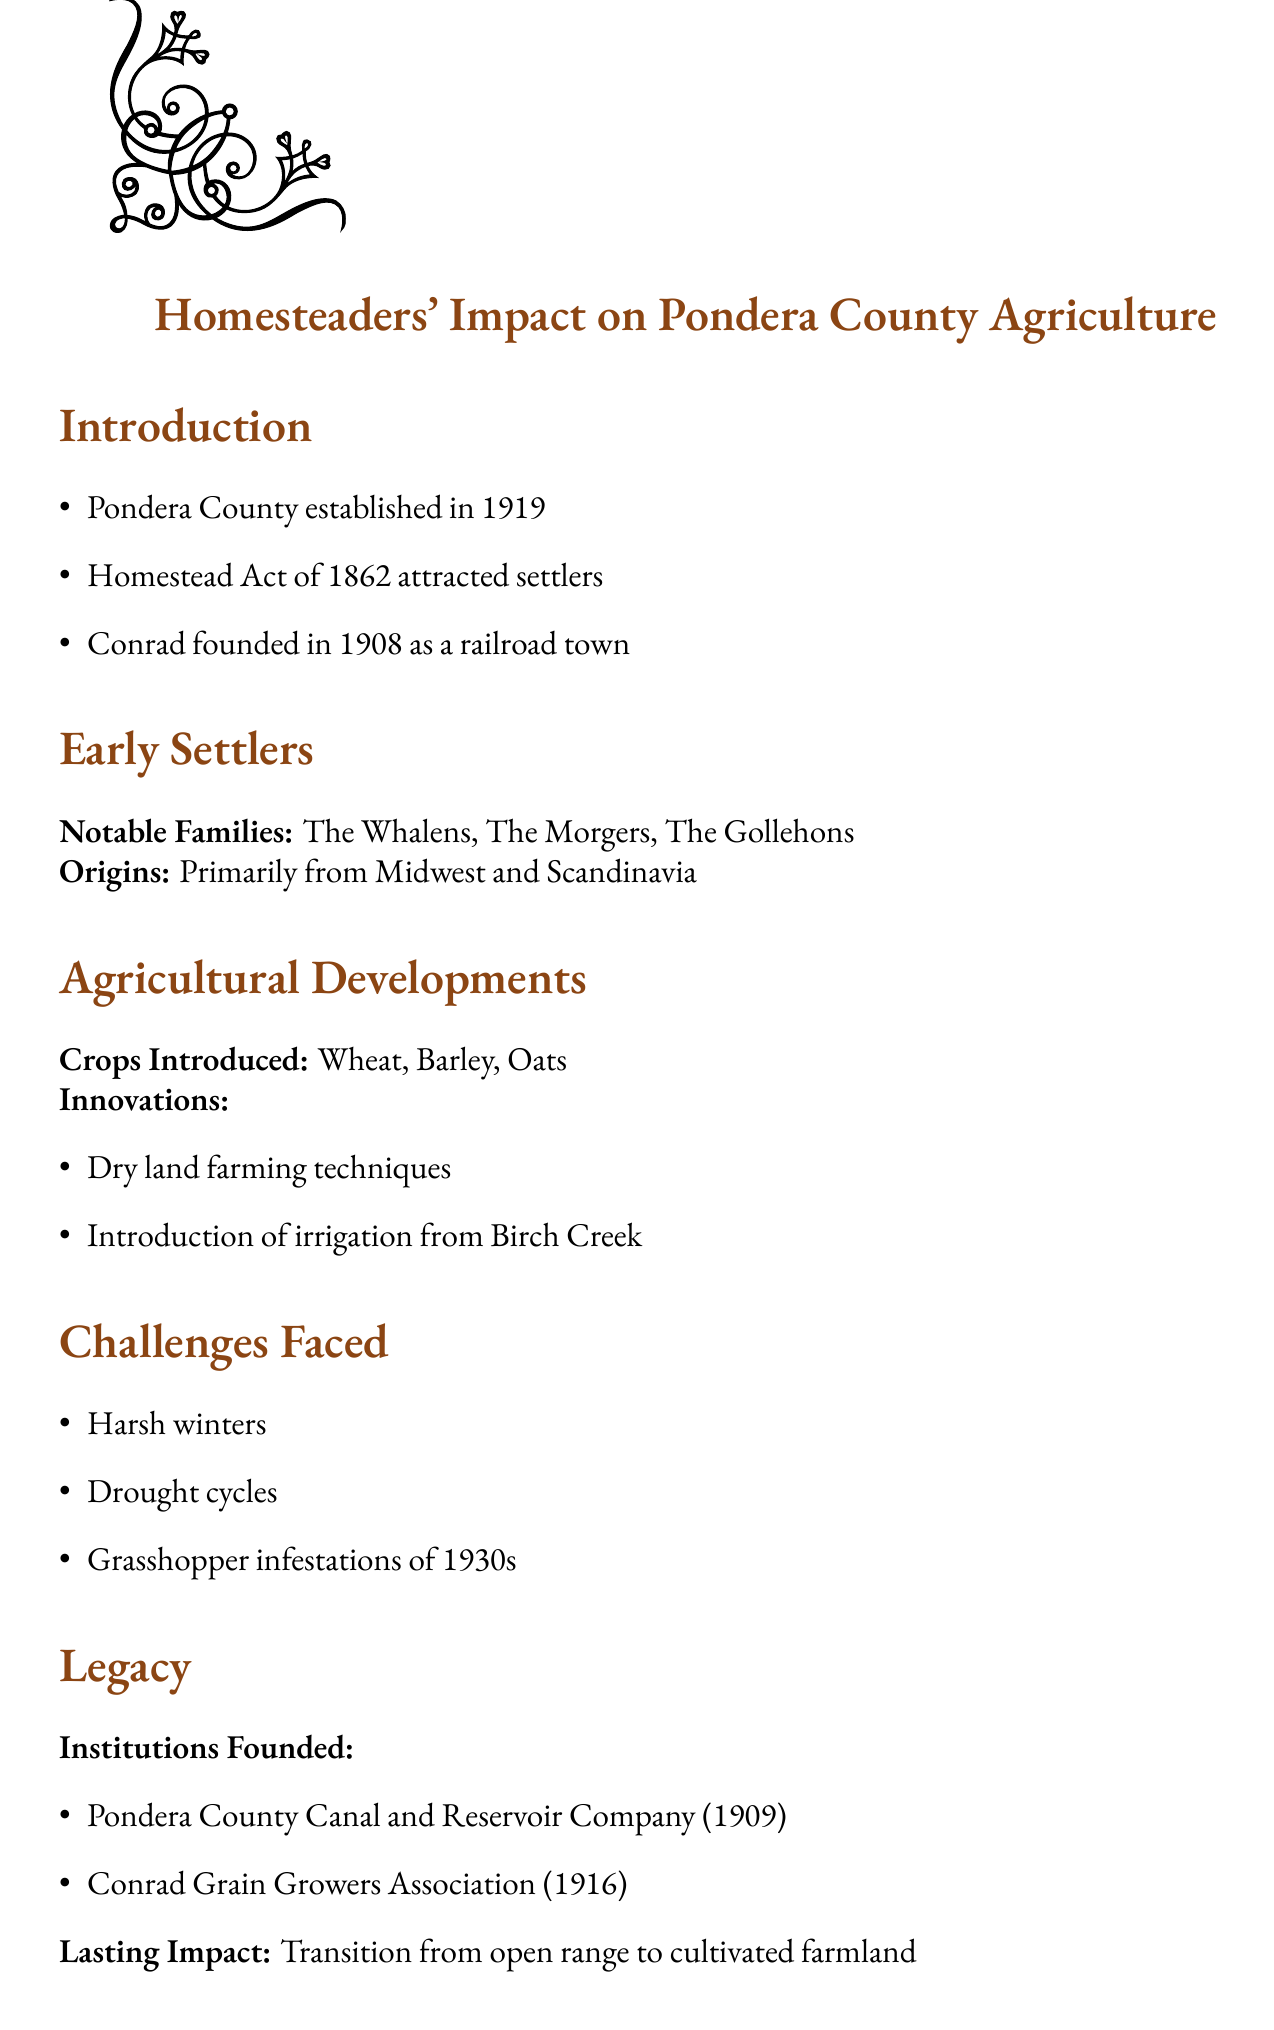What year was Pondera County established? The document states that Pondera County was established in 1919.
Answer: 1919 Which act attracted settlers to Pondera County? The document mentions the Homestead Act of 1862 as the act that attracted settlers.
Answer: Homestead Act of 1862 What notable family is mentioned as an early settler? The document lists notable families, including the Whalens, as early settlers.
Answer: The Whalens What type of farming technique was introduced by homesteaders? The document describes that dry land farming techniques were one of the innovations introduced.
Answer: Dry land farming techniques What challenge did homesteaders face in the 1930s? According to the document, grasshopper infestations were a challenge faced during the 1930s.
Answer: Grasshopper infestations of 1930s What was the lasting impact of homesteaders on Pondera County? The document notes that the lasting impact was the transition from open range to cultivated farmland.
Answer: Transition from open range to cultivated farmland What institution was founded in 1909? The document states that the Pondera County Canal and Reservoir Company was founded in 1909.
Answer: Pondera County Canal and Reservoir Company What crop was introduced by homesteaders? The document lists several crops, including wheat, introduced by homesteaders.
Answer: Wheat How did homesteaders influence modern agriculture? The document concludes that homesteaders laid the foundation for modern agriculture.
Answer: Laid foundation for modern agriculture 